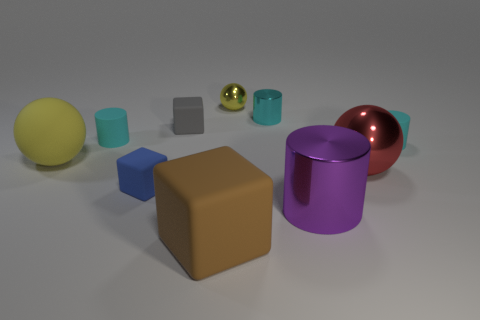There is a cyan matte object to the right of the tiny block in front of the tiny cyan matte thing that is left of the red object; what is its shape? cylinder 